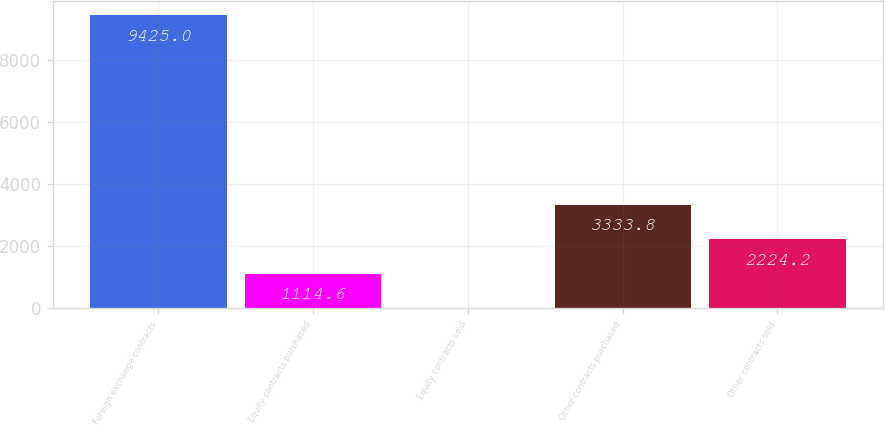<chart> <loc_0><loc_0><loc_500><loc_500><bar_chart><fcel>Foreign exchange contracts<fcel>Equity contracts purchased<fcel>Equity contracts sold<fcel>Other contracts purchased<fcel>Other contracts sold<nl><fcel>9425<fcel>1114.6<fcel>5<fcel>3333.8<fcel>2224.2<nl></chart> 